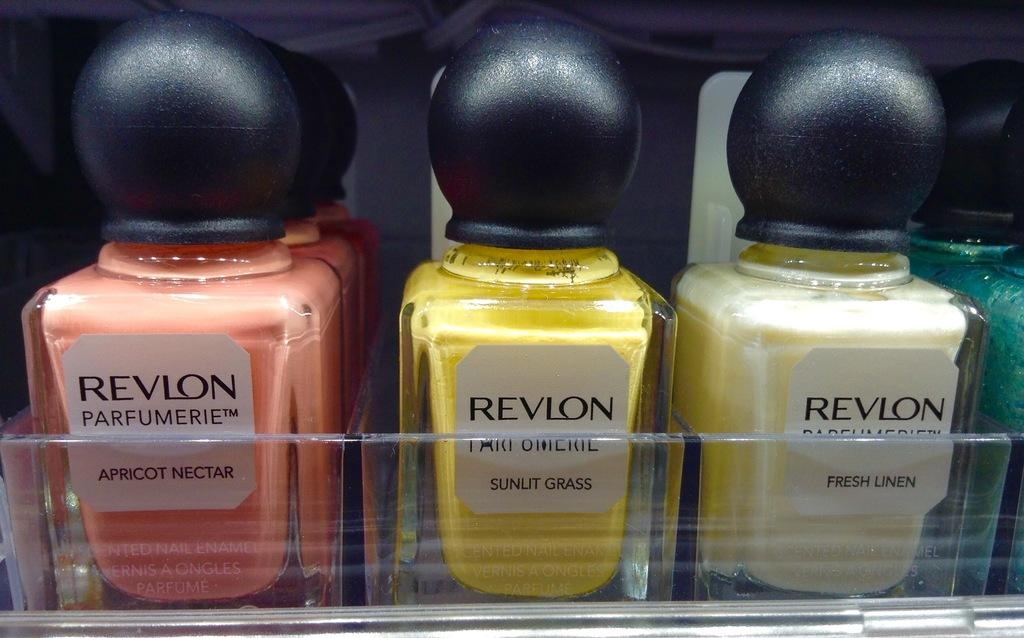Provide a one-sentence caption for the provided image. A number of different Revlon fragrances are displayed on a shelf. 